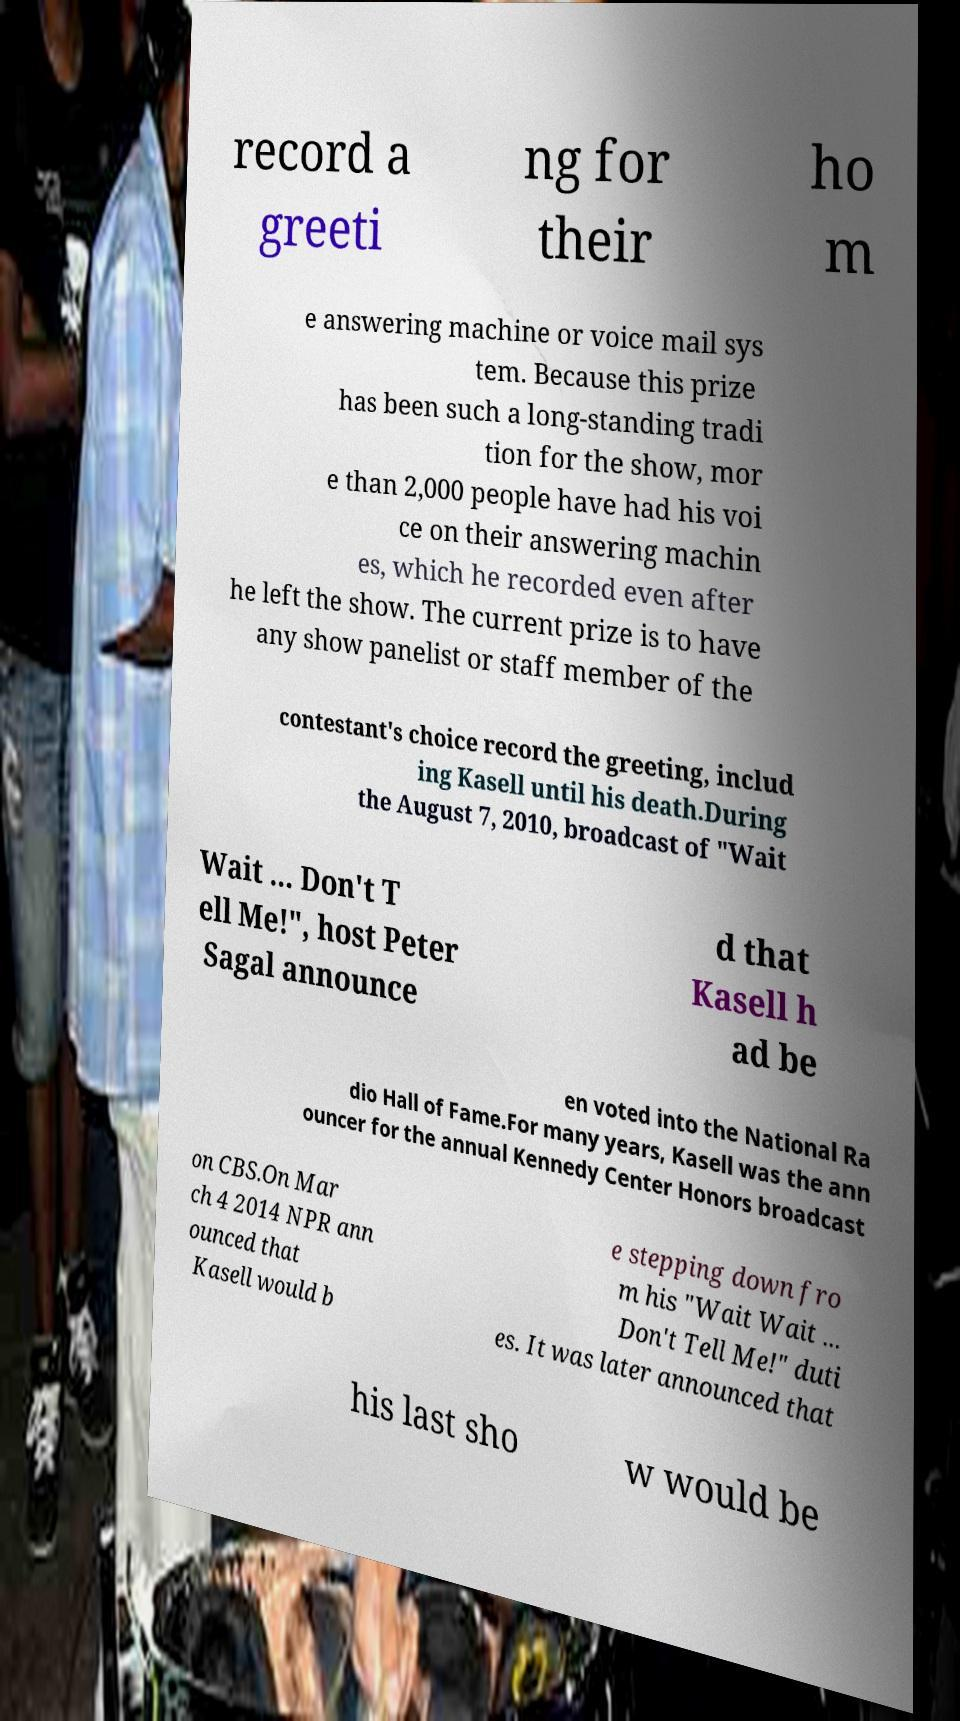Could you extract and type out the text from this image? record a greeti ng for their ho m e answering machine or voice mail sys tem. Because this prize has been such a long-standing tradi tion for the show, mor e than 2,000 people have had his voi ce on their answering machin es, which he recorded even after he left the show. The current prize is to have any show panelist or staff member of the contestant's choice record the greeting, includ ing Kasell until his death.During the August 7, 2010, broadcast of "Wait Wait ... Don't T ell Me!", host Peter Sagal announce d that Kasell h ad be en voted into the National Ra dio Hall of Fame.For many years, Kasell was the ann ouncer for the annual Kennedy Center Honors broadcast on CBS.On Mar ch 4 2014 NPR ann ounced that Kasell would b e stepping down fro m his "Wait Wait ... Don't Tell Me!" duti es. It was later announced that his last sho w would be 